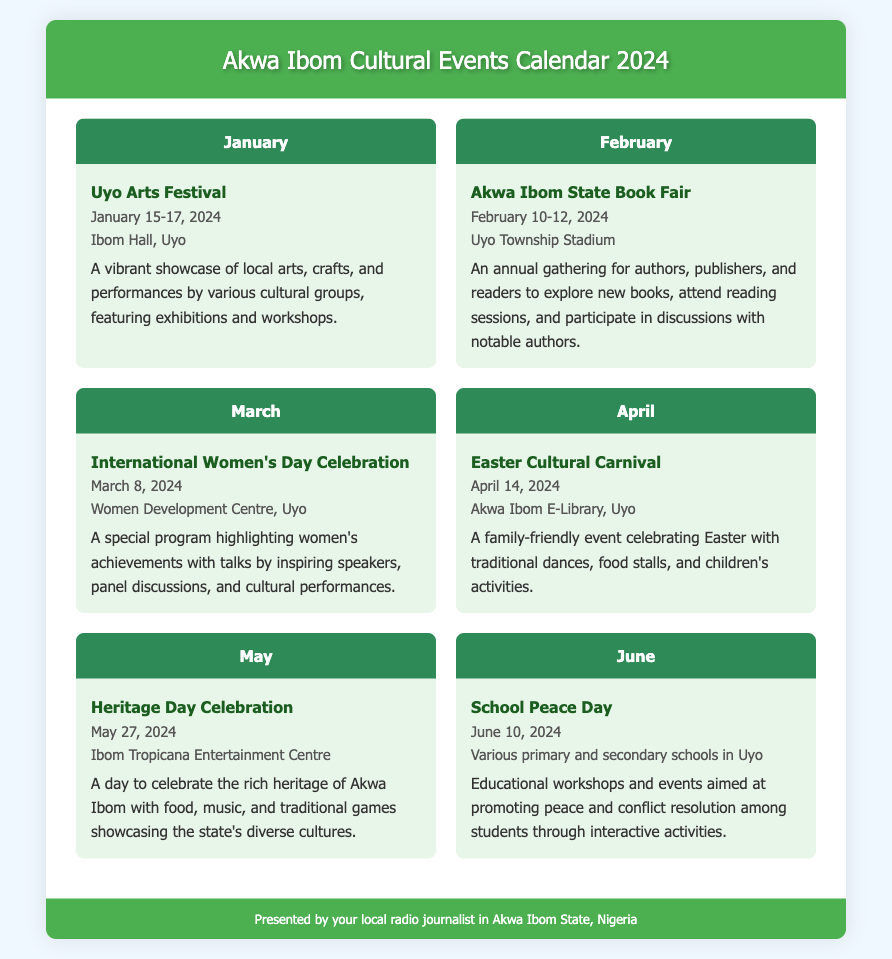What is the first event listed in January? The first event listed in January is "Uyo Arts Festival", which is mentioned at the beginning of the January section.
Answer: Uyo Arts Festival What are the dates for the Akwa Ibom State Book Fair? The dates for the Akwa Ibom State Book Fair are stated in the February section as February 10-12, 2024.
Answer: February 10-12, 2024 Where is the International Women's Day Celebration taking place? The location for the International Women's Day Celebration is specified in the March section as the Women Development Centre, Uyo.
Answer: Women Development Centre, Uyo How many days is the Easter Cultural Carnival? The Easter Cultural Carnival is stated to occur on a single day in the April section, which is April 14, 2024.
Answer: 1 day What type of activities are included in the School Peace Day event? The School Peace Day event includes educational workshops and events aimed at promoting peace and conflict resolution among students.
Answer: Educational workshops Which month features the Heritage Day Celebration? The month featuring the Heritage Day Celebration is clearly stated in the May section.
Answer: May What is the venue for the Uyo Arts Festival? The venue for the Uyo Arts Festival is provided in the January section as Ibom Hall, Uyo.
Answer: Ibom Hall, Uyo What is the theme of the June event listed? The theme of the June event "School Peace Day" focuses on peace and conflict resolution among students as outlined in the document.
Answer: Peace and conflict resolution In which location will the Heritage Day Celebration occur? The location for the Heritage Day Celebration is mentioned as Ibom Tropicana Entertainment Centre in the May section.
Answer: Ibom Tropicana Entertainment Centre 